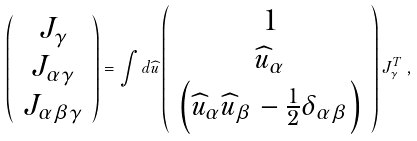Convert formula to latex. <formula><loc_0><loc_0><loc_500><loc_500>\left ( \begin{array} { c } J _ { \gamma } \\ J _ { \alpha \gamma } \\ J _ { \alpha \beta \gamma } \end{array} \right ) = \int d \widehat { u } \left ( \begin{array} { c } 1 \\ \widehat { u } _ { \alpha } \\ \left ( \widehat { u } _ { \alpha } \widehat { u } _ { \beta } - \frac { 1 } { 2 } \delta _ { \alpha \beta } \right ) \end{array} \right ) J _ { \gamma } ^ { T } \, ,</formula> 